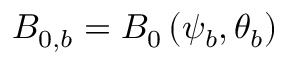Convert formula to latex. <formula><loc_0><loc_0><loc_500><loc_500>B _ { 0 , b } = B _ { 0 } \left ( \psi _ { b } , \theta _ { b } \right )</formula> 